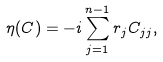<formula> <loc_0><loc_0><loc_500><loc_500>\eta ( C ) = - i \sum _ { j = 1 } ^ { n - 1 } r _ { j } C _ { j j } ,</formula> 